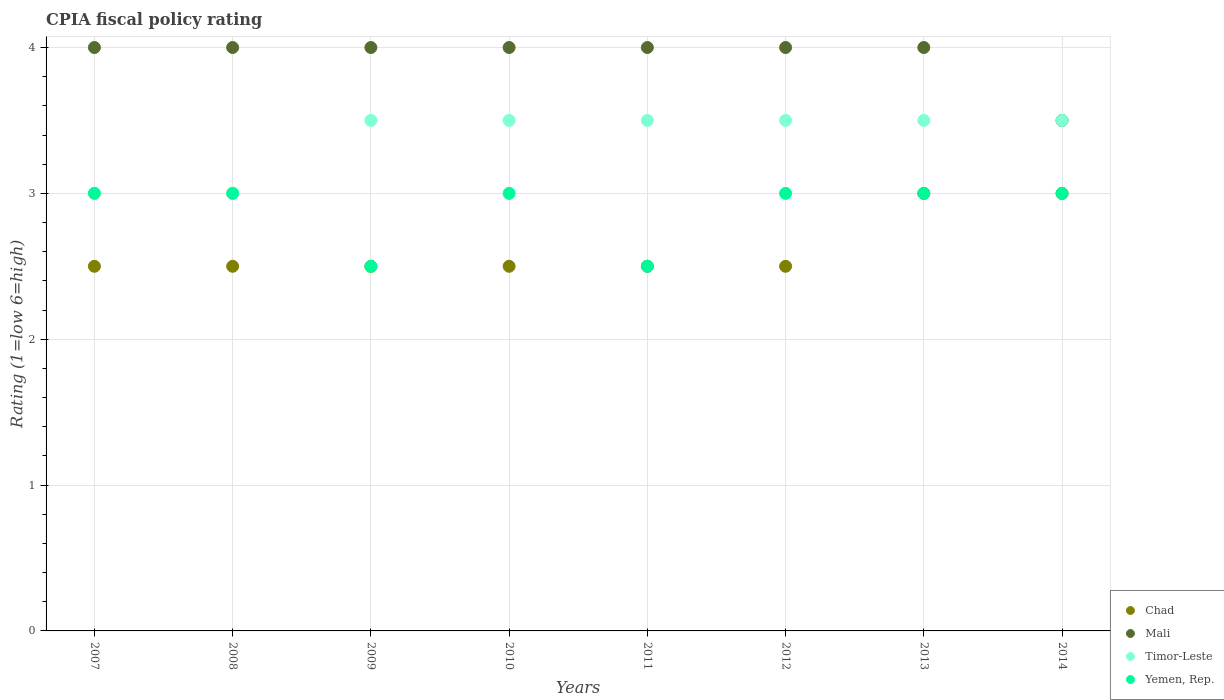Is the number of dotlines equal to the number of legend labels?
Your response must be concise. Yes. Across all years, what is the minimum CPIA rating in Yemen, Rep.?
Your answer should be compact. 2.5. In which year was the CPIA rating in Timor-Leste maximum?
Your response must be concise. 2009. In which year was the CPIA rating in Yemen, Rep. minimum?
Your answer should be very brief. 2009. What is the difference between the CPIA rating in Yemen, Rep. in 2011 and the CPIA rating in Mali in 2012?
Offer a terse response. -1.5. What is the average CPIA rating in Chad per year?
Offer a very short reply. 2.62. In the year 2010, what is the difference between the CPIA rating in Yemen, Rep. and CPIA rating in Chad?
Provide a succinct answer. 0.5. Is the CPIA rating in Chad in 2010 less than that in 2013?
Offer a very short reply. Yes. Is the difference between the CPIA rating in Yemen, Rep. in 2011 and 2013 greater than the difference between the CPIA rating in Chad in 2011 and 2013?
Make the answer very short. No. What is the difference between the highest and the lowest CPIA rating in Chad?
Offer a very short reply. 0.5. In how many years, is the CPIA rating in Mali greater than the average CPIA rating in Mali taken over all years?
Keep it short and to the point. 7. Is it the case that in every year, the sum of the CPIA rating in Chad and CPIA rating in Mali  is greater than the sum of CPIA rating in Yemen, Rep. and CPIA rating in Timor-Leste?
Offer a terse response. Yes. Is it the case that in every year, the sum of the CPIA rating in Timor-Leste and CPIA rating in Chad  is greater than the CPIA rating in Yemen, Rep.?
Offer a terse response. Yes. How many dotlines are there?
Provide a succinct answer. 4. How many years are there in the graph?
Give a very brief answer. 8. Are the values on the major ticks of Y-axis written in scientific E-notation?
Give a very brief answer. No. How many legend labels are there?
Your answer should be very brief. 4. What is the title of the graph?
Provide a short and direct response. CPIA fiscal policy rating. What is the label or title of the X-axis?
Give a very brief answer. Years. What is the Rating (1=low 6=high) of Chad in 2007?
Give a very brief answer. 2.5. What is the Rating (1=low 6=high) in Chad in 2008?
Your answer should be very brief. 2.5. What is the Rating (1=low 6=high) of Timor-Leste in 2008?
Give a very brief answer. 3. What is the Rating (1=low 6=high) of Chad in 2010?
Ensure brevity in your answer.  2.5. What is the Rating (1=low 6=high) of Timor-Leste in 2010?
Provide a short and direct response. 3.5. What is the Rating (1=low 6=high) in Chad in 2011?
Your answer should be compact. 2.5. What is the Rating (1=low 6=high) of Mali in 2011?
Make the answer very short. 4. What is the Rating (1=low 6=high) in Chad in 2012?
Offer a very short reply. 2.5. What is the Rating (1=low 6=high) of Chad in 2013?
Offer a very short reply. 3. What is the Rating (1=low 6=high) in Chad in 2014?
Your answer should be compact. 3. Across all years, what is the maximum Rating (1=low 6=high) of Mali?
Ensure brevity in your answer.  4. Across all years, what is the minimum Rating (1=low 6=high) of Mali?
Provide a short and direct response. 3.5. Across all years, what is the minimum Rating (1=low 6=high) in Timor-Leste?
Your answer should be compact. 3. What is the total Rating (1=low 6=high) in Chad in the graph?
Ensure brevity in your answer.  21. What is the total Rating (1=low 6=high) in Mali in the graph?
Give a very brief answer. 31.5. What is the total Rating (1=low 6=high) in Timor-Leste in the graph?
Offer a terse response. 27. What is the difference between the Rating (1=low 6=high) of Timor-Leste in 2007 and that in 2008?
Offer a terse response. 0. What is the difference between the Rating (1=low 6=high) in Yemen, Rep. in 2007 and that in 2008?
Keep it short and to the point. 0. What is the difference between the Rating (1=low 6=high) of Chad in 2007 and that in 2009?
Keep it short and to the point. 0. What is the difference between the Rating (1=low 6=high) in Mali in 2007 and that in 2010?
Give a very brief answer. 0. What is the difference between the Rating (1=low 6=high) in Yemen, Rep. in 2007 and that in 2010?
Make the answer very short. 0. What is the difference between the Rating (1=low 6=high) in Mali in 2007 and that in 2012?
Make the answer very short. 0. What is the difference between the Rating (1=low 6=high) of Timor-Leste in 2007 and that in 2012?
Ensure brevity in your answer.  -0.5. What is the difference between the Rating (1=low 6=high) of Timor-Leste in 2007 and that in 2013?
Offer a very short reply. -0.5. What is the difference between the Rating (1=low 6=high) in Chad in 2007 and that in 2014?
Offer a very short reply. -0.5. What is the difference between the Rating (1=low 6=high) in Yemen, Rep. in 2007 and that in 2014?
Make the answer very short. 0. What is the difference between the Rating (1=low 6=high) in Mali in 2008 and that in 2009?
Your response must be concise. 0. What is the difference between the Rating (1=low 6=high) in Yemen, Rep. in 2008 and that in 2009?
Provide a short and direct response. 0.5. What is the difference between the Rating (1=low 6=high) of Timor-Leste in 2008 and that in 2010?
Give a very brief answer. -0.5. What is the difference between the Rating (1=low 6=high) in Yemen, Rep. in 2008 and that in 2010?
Your answer should be very brief. 0. What is the difference between the Rating (1=low 6=high) of Chad in 2008 and that in 2011?
Give a very brief answer. 0. What is the difference between the Rating (1=low 6=high) in Yemen, Rep. in 2008 and that in 2011?
Keep it short and to the point. 0.5. What is the difference between the Rating (1=low 6=high) in Chad in 2008 and that in 2012?
Make the answer very short. 0. What is the difference between the Rating (1=low 6=high) of Mali in 2008 and that in 2012?
Your answer should be very brief. 0. What is the difference between the Rating (1=low 6=high) of Yemen, Rep. in 2008 and that in 2012?
Your answer should be compact. 0. What is the difference between the Rating (1=low 6=high) in Mali in 2008 and that in 2013?
Your answer should be very brief. 0. What is the difference between the Rating (1=low 6=high) of Chad in 2008 and that in 2014?
Ensure brevity in your answer.  -0.5. What is the difference between the Rating (1=low 6=high) in Mali in 2009 and that in 2010?
Your answer should be compact. 0. What is the difference between the Rating (1=low 6=high) of Timor-Leste in 2009 and that in 2010?
Your answer should be compact. 0. What is the difference between the Rating (1=low 6=high) of Chad in 2009 and that in 2011?
Ensure brevity in your answer.  0. What is the difference between the Rating (1=low 6=high) of Mali in 2009 and that in 2011?
Your answer should be compact. 0. What is the difference between the Rating (1=low 6=high) of Timor-Leste in 2009 and that in 2011?
Keep it short and to the point. 0. What is the difference between the Rating (1=low 6=high) in Yemen, Rep. in 2009 and that in 2011?
Offer a very short reply. 0. What is the difference between the Rating (1=low 6=high) in Mali in 2009 and that in 2012?
Your response must be concise. 0. What is the difference between the Rating (1=low 6=high) in Timor-Leste in 2009 and that in 2012?
Give a very brief answer. 0. What is the difference between the Rating (1=low 6=high) in Yemen, Rep. in 2009 and that in 2012?
Provide a succinct answer. -0.5. What is the difference between the Rating (1=low 6=high) in Chad in 2009 and that in 2013?
Your answer should be compact. -0.5. What is the difference between the Rating (1=low 6=high) in Timor-Leste in 2009 and that in 2013?
Provide a short and direct response. 0. What is the difference between the Rating (1=low 6=high) of Yemen, Rep. in 2009 and that in 2013?
Your answer should be compact. -0.5. What is the difference between the Rating (1=low 6=high) of Chad in 2009 and that in 2014?
Your answer should be very brief. -0.5. What is the difference between the Rating (1=low 6=high) in Mali in 2009 and that in 2014?
Ensure brevity in your answer.  0.5. What is the difference between the Rating (1=low 6=high) of Chad in 2010 and that in 2011?
Give a very brief answer. 0. What is the difference between the Rating (1=low 6=high) of Chad in 2010 and that in 2012?
Give a very brief answer. 0. What is the difference between the Rating (1=low 6=high) of Mali in 2010 and that in 2012?
Provide a succinct answer. 0. What is the difference between the Rating (1=low 6=high) of Chad in 2010 and that in 2013?
Ensure brevity in your answer.  -0.5. What is the difference between the Rating (1=low 6=high) of Timor-Leste in 2010 and that in 2013?
Your answer should be very brief. 0. What is the difference between the Rating (1=low 6=high) in Chad in 2010 and that in 2014?
Provide a succinct answer. -0.5. What is the difference between the Rating (1=low 6=high) in Mali in 2010 and that in 2014?
Ensure brevity in your answer.  0.5. What is the difference between the Rating (1=low 6=high) in Timor-Leste in 2010 and that in 2014?
Offer a terse response. 0. What is the difference between the Rating (1=low 6=high) of Yemen, Rep. in 2010 and that in 2014?
Your answer should be compact. 0. What is the difference between the Rating (1=low 6=high) of Mali in 2011 and that in 2012?
Provide a short and direct response. 0. What is the difference between the Rating (1=low 6=high) of Timor-Leste in 2011 and that in 2013?
Make the answer very short. 0. What is the difference between the Rating (1=low 6=high) in Yemen, Rep. in 2011 and that in 2013?
Give a very brief answer. -0.5. What is the difference between the Rating (1=low 6=high) of Mali in 2011 and that in 2014?
Your response must be concise. 0.5. What is the difference between the Rating (1=low 6=high) of Yemen, Rep. in 2011 and that in 2014?
Offer a very short reply. -0.5. What is the difference between the Rating (1=low 6=high) of Chad in 2012 and that in 2013?
Offer a very short reply. -0.5. What is the difference between the Rating (1=low 6=high) of Mali in 2012 and that in 2013?
Provide a short and direct response. 0. What is the difference between the Rating (1=low 6=high) in Timor-Leste in 2012 and that in 2013?
Offer a terse response. 0. What is the difference between the Rating (1=low 6=high) of Yemen, Rep. in 2012 and that in 2013?
Offer a terse response. 0. What is the difference between the Rating (1=low 6=high) of Chad in 2012 and that in 2014?
Ensure brevity in your answer.  -0.5. What is the difference between the Rating (1=low 6=high) of Chad in 2013 and that in 2014?
Your answer should be compact. 0. What is the difference between the Rating (1=low 6=high) in Mali in 2013 and that in 2014?
Keep it short and to the point. 0.5. What is the difference between the Rating (1=low 6=high) of Chad in 2007 and the Rating (1=low 6=high) of Mali in 2008?
Provide a succinct answer. -1.5. What is the difference between the Rating (1=low 6=high) in Chad in 2007 and the Rating (1=low 6=high) in Timor-Leste in 2008?
Offer a terse response. -0.5. What is the difference between the Rating (1=low 6=high) of Chad in 2007 and the Rating (1=low 6=high) of Yemen, Rep. in 2008?
Your response must be concise. -0.5. What is the difference between the Rating (1=low 6=high) in Mali in 2007 and the Rating (1=low 6=high) in Timor-Leste in 2008?
Your answer should be compact. 1. What is the difference between the Rating (1=low 6=high) of Mali in 2007 and the Rating (1=low 6=high) of Yemen, Rep. in 2008?
Offer a terse response. 1. What is the difference between the Rating (1=low 6=high) of Timor-Leste in 2007 and the Rating (1=low 6=high) of Yemen, Rep. in 2008?
Your answer should be very brief. 0. What is the difference between the Rating (1=low 6=high) in Chad in 2007 and the Rating (1=low 6=high) in Mali in 2009?
Keep it short and to the point. -1.5. What is the difference between the Rating (1=low 6=high) in Chad in 2007 and the Rating (1=low 6=high) in Timor-Leste in 2009?
Give a very brief answer. -1. What is the difference between the Rating (1=low 6=high) of Chad in 2007 and the Rating (1=low 6=high) of Yemen, Rep. in 2009?
Keep it short and to the point. 0. What is the difference between the Rating (1=low 6=high) of Mali in 2007 and the Rating (1=low 6=high) of Timor-Leste in 2009?
Offer a very short reply. 0.5. What is the difference between the Rating (1=low 6=high) in Mali in 2007 and the Rating (1=low 6=high) in Yemen, Rep. in 2009?
Keep it short and to the point. 1.5. What is the difference between the Rating (1=low 6=high) in Timor-Leste in 2007 and the Rating (1=low 6=high) in Yemen, Rep. in 2009?
Provide a short and direct response. 0.5. What is the difference between the Rating (1=low 6=high) in Chad in 2007 and the Rating (1=low 6=high) in Yemen, Rep. in 2010?
Your response must be concise. -0.5. What is the difference between the Rating (1=low 6=high) of Mali in 2007 and the Rating (1=low 6=high) of Yemen, Rep. in 2010?
Ensure brevity in your answer.  1. What is the difference between the Rating (1=low 6=high) in Chad in 2007 and the Rating (1=low 6=high) in Mali in 2011?
Offer a very short reply. -1.5. What is the difference between the Rating (1=low 6=high) in Chad in 2007 and the Rating (1=low 6=high) in Timor-Leste in 2011?
Your response must be concise. -1. What is the difference between the Rating (1=low 6=high) of Chad in 2007 and the Rating (1=low 6=high) of Yemen, Rep. in 2011?
Provide a succinct answer. 0. What is the difference between the Rating (1=low 6=high) of Timor-Leste in 2007 and the Rating (1=low 6=high) of Yemen, Rep. in 2011?
Ensure brevity in your answer.  0.5. What is the difference between the Rating (1=low 6=high) of Chad in 2007 and the Rating (1=low 6=high) of Mali in 2012?
Provide a short and direct response. -1.5. What is the difference between the Rating (1=low 6=high) in Chad in 2007 and the Rating (1=low 6=high) in Timor-Leste in 2012?
Your response must be concise. -1. What is the difference between the Rating (1=low 6=high) in Chad in 2007 and the Rating (1=low 6=high) in Yemen, Rep. in 2012?
Make the answer very short. -0.5. What is the difference between the Rating (1=low 6=high) of Mali in 2007 and the Rating (1=low 6=high) of Timor-Leste in 2012?
Provide a short and direct response. 0.5. What is the difference between the Rating (1=low 6=high) of Timor-Leste in 2007 and the Rating (1=low 6=high) of Yemen, Rep. in 2012?
Ensure brevity in your answer.  0. What is the difference between the Rating (1=low 6=high) of Chad in 2007 and the Rating (1=low 6=high) of Mali in 2013?
Offer a terse response. -1.5. What is the difference between the Rating (1=low 6=high) in Chad in 2007 and the Rating (1=low 6=high) in Timor-Leste in 2013?
Ensure brevity in your answer.  -1. What is the difference between the Rating (1=low 6=high) in Chad in 2007 and the Rating (1=low 6=high) in Yemen, Rep. in 2013?
Offer a very short reply. -0.5. What is the difference between the Rating (1=low 6=high) of Mali in 2007 and the Rating (1=low 6=high) of Timor-Leste in 2013?
Provide a short and direct response. 0.5. What is the difference between the Rating (1=low 6=high) of Mali in 2007 and the Rating (1=low 6=high) of Yemen, Rep. in 2013?
Your answer should be very brief. 1. What is the difference between the Rating (1=low 6=high) in Mali in 2007 and the Rating (1=low 6=high) in Timor-Leste in 2014?
Make the answer very short. 0.5. What is the difference between the Rating (1=low 6=high) of Mali in 2007 and the Rating (1=low 6=high) of Yemen, Rep. in 2014?
Offer a terse response. 1. What is the difference between the Rating (1=low 6=high) of Timor-Leste in 2007 and the Rating (1=low 6=high) of Yemen, Rep. in 2014?
Offer a terse response. 0. What is the difference between the Rating (1=low 6=high) in Chad in 2008 and the Rating (1=low 6=high) in Mali in 2009?
Offer a terse response. -1.5. What is the difference between the Rating (1=low 6=high) of Chad in 2008 and the Rating (1=low 6=high) of Yemen, Rep. in 2009?
Offer a very short reply. 0. What is the difference between the Rating (1=low 6=high) of Mali in 2008 and the Rating (1=low 6=high) of Yemen, Rep. in 2009?
Keep it short and to the point. 1.5. What is the difference between the Rating (1=low 6=high) in Timor-Leste in 2008 and the Rating (1=low 6=high) in Yemen, Rep. in 2009?
Keep it short and to the point. 0.5. What is the difference between the Rating (1=low 6=high) in Chad in 2008 and the Rating (1=low 6=high) in Yemen, Rep. in 2010?
Offer a very short reply. -0.5. What is the difference between the Rating (1=low 6=high) of Mali in 2008 and the Rating (1=low 6=high) of Yemen, Rep. in 2010?
Offer a terse response. 1. What is the difference between the Rating (1=low 6=high) of Timor-Leste in 2008 and the Rating (1=low 6=high) of Yemen, Rep. in 2010?
Your response must be concise. 0. What is the difference between the Rating (1=low 6=high) in Chad in 2008 and the Rating (1=low 6=high) in Timor-Leste in 2011?
Make the answer very short. -1. What is the difference between the Rating (1=low 6=high) in Chad in 2008 and the Rating (1=low 6=high) in Yemen, Rep. in 2011?
Your answer should be very brief. 0. What is the difference between the Rating (1=low 6=high) of Mali in 2008 and the Rating (1=low 6=high) of Timor-Leste in 2011?
Make the answer very short. 0.5. What is the difference between the Rating (1=low 6=high) in Mali in 2008 and the Rating (1=low 6=high) in Yemen, Rep. in 2011?
Offer a very short reply. 1.5. What is the difference between the Rating (1=low 6=high) of Chad in 2008 and the Rating (1=low 6=high) of Timor-Leste in 2012?
Your answer should be very brief. -1. What is the difference between the Rating (1=low 6=high) of Chad in 2008 and the Rating (1=low 6=high) of Mali in 2013?
Offer a very short reply. -1.5. What is the difference between the Rating (1=low 6=high) in Mali in 2008 and the Rating (1=low 6=high) in Timor-Leste in 2013?
Ensure brevity in your answer.  0.5. What is the difference between the Rating (1=low 6=high) in Mali in 2008 and the Rating (1=low 6=high) in Yemen, Rep. in 2013?
Offer a very short reply. 1. What is the difference between the Rating (1=low 6=high) of Timor-Leste in 2008 and the Rating (1=low 6=high) of Yemen, Rep. in 2013?
Your response must be concise. 0. What is the difference between the Rating (1=low 6=high) in Chad in 2008 and the Rating (1=low 6=high) in Mali in 2014?
Make the answer very short. -1. What is the difference between the Rating (1=low 6=high) of Chad in 2008 and the Rating (1=low 6=high) of Timor-Leste in 2014?
Ensure brevity in your answer.  -1. What is the difference between the Rating (1=low 6=high) in Mali in 2008 and the Rating (1=low 6=high) in Yemen, Rep. in 2014?
Provide a succinct answer. 1. What is the difference between the Rating (1=low 6=high) of Timor-Leste in 2008 and the Rating (1=low 6=high) of Yemen, Rep. in 2014?
Ensure brevity in your answer.  0. What is the difference between the Rating (1=low 6=high) of Chad in 2009 and the Rating (1=low 6=high) of Mali in 2010?
Provide a succinct answer. -1.5. What is the difference between the Rating (1=low 6=high) in Chad in 2009 and the Rating (1=low 6=high) in Timor-Leste in 2010?
Your answer should be very brief. -1. What is the difference between the Rating (1=low 6=high) of Chad in 2009 and the Rating (1=low 6=high) of Yemen, Rep. in 2010?
Offer a very short reply. -0.5. What is the difference between the Rating (1=low 6=high) of Chad in 2009 and the Rating (1=low 6=high) of Mali in 2011?
Your answer should be very brief. -1.5. What is the difference between the Rating (1=low 6=high) in Chad in 2009 and the Rating (1=low 6=high) in Yemen, Rep. in 2011?
Keep it short and to the point. 0. What is the difference between the Rating (1=low 6=high) in Mali in 2009 and the Rating (1=low 6=high) in Timor-Leste in 2011?
Your answer should be very brief. 0.5. What is the difference between the Rating (1=low 6=high) in Timor-Leste in 2009 and the Rating (1=low 6=high) in Yemen, Rep. in 2011?
Offer a very short reply. 1. What is the difference between the Rating (1=low 6=high) in Chad in 2009 and the Rating (1=low 6=high) in Timor-Leste in 2012?
Offer a very short reply. -1. What is the difference between the Rating (1=low 6=high) of Chad in 2009 and the Rating (1=low 6=high) of Yemen, Rep. in 2012?
Give a very brief answer. -0.5. What is the difference between the Rating (1=low 6=high) in Mali in 2009 and the Rating (1=low 6=high) in Timor-Leste in 2012?
Provide a succinct answer. 0.5. What is the difference between the Rating (1=low 6=high) of Timor-Leste in 2009 and the Rating (1=low 6=high) of Yemen, Rep. in 2012?
Provide a succinct answer. 0.5. What is the difference between the Rating (1=low 6=high) of Chad in 2009 and the Rating (1=low 6=high) of Mali in 2013?
Provide a succinct answer. -1.5. What is the difference between the Rating (1=low 6=high) of Chad in 2009 and the Rating (1=low 6=high) of Yemen, Rep. in 2013?
Your response must be concise. -0.5. What is the difference between the Rating (1=low 6=high) of Mali in 2009 and the Rating (1=low 6=high) of Yemen, Rep. in 2013?
Provide a short and direct response. 1. What is the difference between the Rating (1=low 6=high) of Chad in 2009 and the Rating (1=low 6=high) of Mali in 2014?
Ensure brevity in your answer.  -1. What is the difference between the Rating (1=low 6=high) of Chad in 2009 and the Rating (1=low 6=high) of Timor-Leste in 2014?
Your response must be concise. -1. What is the difference between the Rating (1=low 6=high) in Chad in 2009 and the Rating (1=low 6=high) in Yemen, Rep. in 2014?
Provide a succinct answer. -0.5. What is the difference between the Rating (1=low 6=high) of Mali in 2009 and the Rating (1=low 6=high) of Yemen, Rep. in 2014?
Ensure brevity in your answer.  1. What is the difference between the Rating (1=low 6=high) of Timor-Leste in 2009 and the Rating (1=low 6=high) of Yemen, Rep. in 2014?
Give a very brief answer. 0.5. What is the difference between the Rating (1=low 6=high) in Chad in 2010 and the Rating (1=low 6=high) in Mali in 2011?
Keep it short and to the point. -1.5. What is the difference between the Rating (1=low 6=high) in Chad in 2010 and the Rating (1=low 6=high) in Yemen, Rep. in 2011?
Your answer should be very brief. 0. What is the difference between the Rating (1=low 6=high) in Mali in 2010 and the Rating (1=low 6=high) in Timor-Leste in 2011?
Keep it short and to the point. 0.5. What is the difference between the Rating (1=low 6=high) of Chad in 2010 and the Rating (1=low 6=high) of Mali in 2012?
Make the answer very short. -1.5. What is the difference between the Rating (1=low 6=high) in Chad in 2010 and the Rating (1=low 6=high) in Timor-Leste in 2012?
Make the answer very short. -1. What is the difference between the Rating (1=low 6=high) of Chad in 2010 and the Rating (1=low 6=high) of Yemen, Rep. in 2012?
Make the answer very short. -0.5. What is the difference between the Rating (1=low 6=high) of Timor-Leste in 2010 and the Rating (1=low 6=high) of Yemen, Rep. in 2012?
Your response must be concise. 0.5. What is the difference between the Rating (1=low 6=high) of Chad in 2010 and the Rating (1=low 6=high) of Timor-Leste in 2013?
Offer a terse response. -1. What is the difference between the Rating (1=low 6=high) in Mali in 2010 and the Rating (1=low 6=high) in Timor-Leste in 2013?
Offer a terse response. 0.5. What is the difference between the Rating (1=low 6=high) of Timor-Leste in 2010 and the Rating (1=low 6=high) of Yemen, Rep. in 2013?
Provide a short and direct response. 0.5. What is the difference between the Rating (1=low 6=high) in Chad in 2010 and the Rating (1=low 6=high) in Mali in 2014?
Your response must be concise. -1. What is the difference between the Rating (1=low 6=high) of Mali in 2010 and the Rating (1=low 6=high) of Yemen, Rep. in 2014?
Provide a succinct answer. 1. What is the difference between the Rating (1=low 6=high) of Timor-Leste in 2010 and the Rating (1=low 6=high) of Yemen, Rep. in 2014?
Offer a terse response. 0.5. What is the difference between the Rating (1=low 6=high) of Chad in 2011 and the Rating (1=low 6=high) of Mali in 2012?
Provide a short and direct response. -1.5. What is the difference between the Rating (1=low 6=high) in Chad in 2011 and the Rating (1=low 6=high) in Timor-Leste in 2012?
Ensure brevity in your answer.  -1. What is the difference between the Rating (1=low 6=high) of Mali in 2011 and the Rating (1=low 6=high) of Yemen, Rep. in 2012?
Keep it short and to the point. 1. What is the difference between the Rating (1=low 6=high) in Chad in 2011 and the Rating (1=low 6=high) in Timor-Leste in 2013?
Your response must be concise. -1. What is the difference between the Rating (1=low 6=high) of Mali in 2011 and the Rating (1=low 6=high) of Timor-Leste in 2013?
Your response must be concise. 0.5. What is the difference between the Rating (1=low 6=high) in Timor-Leste in 2011 and the Rating (1=low 6=high) in Yemen, Rep. in 2013?
Provide a short and direct response. 0.5. What is the difference between the Rating (1=low 6=high) of Chad in 2011 and the Rating (1=low 6=high) of Mali in 2014?
Your answer should be compact. -1. What is the difference between the Rating (1=low 6=high) of Chad in 2011 and the Rating (1=low 6=high) of Timor-Leste in 2014?
Provide a succinct answer. -1. What is the difference between the Rating (1=low 6=high) in Chad in 2011 and the Rating (1=low 6=high) in Yemen, Rep. in 2014?
Provide a succinct answer. -0.5. What is the difference between the Rating (1=low 6=high) in Mali in 2011 and the Rating (1=low 6=high) in Timor-Leste in 2014?
Keep it short and to the point. 0.5. What is the difference between the Rating (1=low 6=high) in Mali in 2011 and the Rating (1=low 6=high) in Yemen, Rep. in 2014?
Your answer should be compact. 1. What is the difference between the Rating (1=low 6=high) in Chad in 2012 and the Rating (1=low 6=high) in Mali in 2013?
Offer a terse response. -1.5. What is the difference between the Rating (1=low 6=high) in Chad in 2012 and the Rating (1=low 6=high) in Timor-Leste in 2013?
Offer a terse response. -1. What is the difference between the Rating (1=low 6=high) in Chad in 2012 and the Rating (1=low 6=high) in Mali in 2014?
Your response must be concise. -1. What is the difference between the Rating (1=low 6=high) of Chad in 2012 and the Rating (1=low 6=high) of Yemen, Rep. in 2014?
Offer a very short reply. -0.5. What is the difference between the Rating (1=low 6=high) of Mali in 2012 and the Rating (1=low 6=high) of Timor-Leste in 2014?
Your answer should be very brief. 0.5. What is the difference between the Rating (1=low 6=high) in Timor-Leste in 2012 and the Rating (1=low 6=high) in Yemen, Rep. in 2014?
Give a very brief answer. 0.5. What is the difference between the Rating (1=low 6=high) in Chad in 2013 and the Rating (1=low 6=high) in Mali in 2014?
Your answer should be compact. -0.5. What is the difference between the Rating (1=low 6=high) of Mali in 2013 and the Rating (1=low 6=high) of Timor-Leste in 2014?
Keep it short and to the point. 0.5. What is the difference between the Rating (1=low 6=high) in Timor-Leste in 2013 and the Rating (1=low 6=high) in Yemen, Rep. in 2014?
Offer a terse response. 0.5. What is the average Rating (1=low 6=high) of Chad per year?
Give a very brief answer. 2.62. What is the average Rating (1=low 6=high) in Mali per year?
Provide a succinct answer. 3.94. What is the average Rating (1=low 6=high) in Timor-Leste per year?
Provide a short and direct response. 3.38. What is the average Rating (1=low 6=high) of Yemen, Rep. per year?
Provide a short and direct response. 2.88. In the year 2007, what is the difference between the Rating (1=low 6=high) in Timor-Leste and Rating (1=low 6=high) in Yemen, Rep.?
Your answer should be very brief. 0. In the year 2008, what is the difference between the Rating (1=low 6=high) of Chad and Rating (1=low 6=high) of Timor-Leste?
Provide a short and direct response. -0.5. In the year 2008, what is the difference between the Rating (1=low 6=high) in Mali and Rating (1=low 6=high) in Yemen, Rep.?
Offer a very short reply. 1. In the year 2008, what is the difference between the Rating (1=low 6=high) of Timor-Leste and Rating (1=low 6=high) of Yemen, Rep.?
Your answer should be very brief. 0. In the year 2009, what is the difference between the Rating (1=low 6=high) in Chad and Rating (1=low 6=high) in Mali?
Ensure brevity in your answer.  -1.5. In the year 2009, what is the difference between the Rating (1=low 6=high) of Chad and Rating (1=low 6=high) of Yemen, Rep.?
Make the answer very short. 0. In the year 2009, what is the difference between the Rating (1=low 6=high) in Mali and Rating (1=low 6=high) in Yemen, Rep.?
Keep it short and to the point. 1.5. In the year 2010, what is the difference between the Rating (1=low 6=high) in Chad and Rating (1=low 6=high) in Mali?
Offer a very short reply. -1.5. In the year 2010, what is the difference between the Rating (1=low 6=high) of Chad and Rating (1=low 6=high) of Timor-Leste?
Your answer should be compact. -1. In the year 2010, what is the difference between the Rating (1=low 6=high) of Chad and Rating (1=low 6=high) of Yemen, Rep.?
Your answer should be compact. -0.5. In the year 2010, what is the difference between the Rating (1=low 6=high) of Mali and Rating (1=low 6=high) of Yemen, Rep.?
Give a very brief answer. 1. In the year 2010, what is the difference between the Rating (1=low 6=high) of Timor-Leste and Rating (1=low 6=high) of Yemen, Rep.?
Your answer should be very brief. 0.5. In the year 2011, what is the difference between the Rating (1=low 6=high) of Chad and Rating (1=low 6=high) of Mali?
Offer a terse response. -1.5. In the year 2011, what is the difference between the Rating (1=low 6=high) in Chad and Rating (1=low 6=high) in Timor-Leste?
Provide a short and direct response. -1. In the year 2011, what is the difference between the Rating (1=low 6=high) in Mali and Rating (1=low 6=high) in Yemen, Rep.?
Make the answer very short. 1.5. In the year 2011, what is the difference between the Rating (1=low 6=high) of Timor-Leste and Rating (1=low 6=high) of Yemen, Rep.?
Provide a succinct answer. 1. In the year 2012, what is the difference between the Rating (1=low 6=high) of Chad and Rating (1=low 6=high) of Yemen, Rep.?
Your answer should be compact. -0.5. In the year 2013, what is the difference between the Rating (1=low 6=high) of Chad and Rating (1=low 6=high) of Mali?
Your response must be concise. -1. In the year 2013, what is the difference between the Rating (1=low 6=high) of Mali and Rating (1=low 6=high) of Timor-Leste?
Provide a succinct answer. 0.5. In the year 2013, what is the difference between the Rating (1=low 6=high) in Timor-Leste and Rating (1=low 6=high) in Yemen, Rep.?
Provide a short and direct response. 0.5. In the year 2014, what is the difference between the Rating (1=low 6=high) in Chad and Rating (1=low 6=high) in Yemen, Rep.?
Offer a terse response. 0. In the year 2014, what is the difference between the Rating (1=low 6=high) of Mali and Rating (1=low 6=high) of Timor-Leste?
Provide a short and direct response. 0. In the year 2014, what is the difference between the Rating (1=low 6=high) of Mali and Rating (1=low 6=high) of Yemen, Rep.?
Make the answer very short. 0.5. What is the ratio of the Rating (1=low 6=high) of Mali in 2007 to that in 2008?
Give a very brief answer. 1. What is the ratio of the Rating (1=low 6=high) in Timor-Leste in 2007 to that in 2008?
Make the answer very short. 1. What is the ratio of the Rating (1=low 6=high) of Yemen, Rep. in 2007 to that in 2008?
Your answer should be compact. 1. What is the ratio of the Rating (1=low 6=high) of Chad in 2007 to that in 2009?
Provide a succinct answer. 1. What is the ratio of the Rating (1=low 6=high) of Mali in 2007 to that in 2009?
Give a very brief answer. 1. What is the ratio of the Rating (1=low 6=high) of Timor-Leste in 2007 to that in 2009?
Offer a terse response. 0.86. What is the ratio of the Rating (1=low 6=high) of Yemen, Rep. in 2007 to that in 2009?
Give a very brief answer. 1.2. What is the ratio of the Rating (1=low 6=high) in Chad in 2007 to that in 2010?
Your answer should be very brief. 1. What is the ratio of the Rating (1=low 6=high) of Mali in 2007 to that in 2010?
Ensure brevity in your answer.  1. What is the ratio of the Rating (1=low 6=high) of Mali in 2007 to that in 2011?
Offer a very short reply. 1. What is the ratio of the Rating (1=low 6=high) in Timor-Leste in 2007 to that in 2011?
Keep it short and to the point. 0.86. What is the ratio of the Rating (1=low 6=high) in Mali in 2007 to that in 2012?
Offer a terse response. 1. What is the ratio of the Rating (1=low 6=high) of Yemen, Rep. in 2007 to that in 2012?
Provide a short and direct response. 1. What is the ratio of the Rating (1=low 6=high) in Mali in 2007 to that in 2013?
Give a very brief answer. 1. What is the ratio of the Rating (1=low 6=high) in Yemen, Rep. in 2007 to that in 2013?
Offer a terse response. 1. What is the ratio of the Rating (1=low 6=high) in Mali in 2007 to that in 2014?
Make the answer very short. 1.14. What is the ratio of the Rating (1=low 6=high) in Yemen, Rep. in 2007 to that in 2014?
Provide a succinct answer. 1. What is the ratio of the Rating (1=low 6=high) of Chad in 2008 to that in 2009?
Your answer should be very brief. 1. What is the ratio of the Rating (1=low 6=high) of Yemen, Rep. in 2008 to that in 2009?
Give a very brief answer. 1.2. What is the ratio of the Rating (1=low 6=high) of Timor-Leste in 2008 to that in 2010?
Offer a very short reply. 0.86. What is the ratio of the Rating (1=low 6=high) in Yemen, Rep. in 2008 to that in 2010?
Provide a short and direct response. 1. What is the ratio of the Rating (1=low 6=high) in Timor-Leste in 2008 to that in 2011?
Your response must be concise. 0.86. What is the ratio of the Rating (1=low 6=high) in Yemen, Rep. in 2008 to that in 2011?
Make the answer very short. 1.2. What is the ratio of the Rating (1=low 6=high) in Chad in 2008 to that in 2012?
Your answer should be compact. 1. What is the ratio of the Rating (1=low 6=high) of Chad in 2008 to that in 2013?
Your answer should be very brief. 0.83. What is the ratio of the Rating (1=low 6=high) of Mali in 2008 to that in 2013?
Make the answer very short. 1. What is the ratio of the Rating (1=low 6=high) of Yemen, Rep. in 2008 to that in 2013?
Offer a terse response. 1. What is the ratio of the Rating (1=low 6=high) in Chad in 2008 to that in 2014?
Provide a succinct answer. 0.83. What is the ratio of the Rating (1=low 6=high) of Timor-Leste in 2008 to that in 2014?
Offer a very short reply. 0.86. What is the ratio of the Rating (1=low 6=high) in Chad in 2009 to that in 2010?
Provide a succinct answer. 1. What is the ratio of the Rating (1=low 6=high) in Timor-Leste in 2009 to that in 2010?
Ensure brevity in your answer.  1. What is the ratio of the Rating (1=low 6=high) in Yemen, Rep. in 2009 to that in 2010?
Provide a succinct answer. 0.83. What is the ratio of the Rating (1=low 6=high) of Mali in 2009 to that in 2011?
Give a very brief answer. 1. What is the ratio of the Rating (1=low 6=high) in Chad in 2009 to that in 2012?
Your answer should be compact. 1. What is the ratio of the Rating (1=low 6=high) of Mali in 2009 to that in 2012?
Your answer should be compact. 1. What is the ratio of the Rating (1=low 6=high) in Yemen, Rep. in 2009 to that in 2012?
Your response must be concise. 0.83. What is the ratio of the Rating (1=low 6=high) in Mali in 2009 to that in 2013?
Offer a terse response. 1. What is the ratio of the Rating (1=low 6=high) of Chad in 2009 to that in 2014?
Provide a short and direct response. 0.83. What is the ratio of the Rating (1=low 6=high) in Mali in 2009 to that in 2014?
Your response must be concise. 1.14. What is the ratio of the Rating (1=low 6=high) in Mali in 2010 to that in 2011?
Provide a succinct answer. 1. What is the ratio of the Rating (1=low 6=high) of Timor-Leste in 2010 to that in 2011?
Offer a terse response. 1. What is the ratio of the Rating (1=low 6=high) in Yemen, Rep. in 2010 to that in 2011?
Keep it short and to the point. 1.2. What is the ratio of the Rating (1=low 6=high) of Mali in 2010 to that in 2012?
Give a very brief answer. 1. What is the ratio of the Rating (1=low 6=high) in Chad in 2010 to that in 2013?
Give a very brief answer. 0.83. What is the ratio of the Rating (1=low 6=high) in Mali in 2010 to that in 2013?
Your answer should be compact. 1. What is the ratio of the Rating (1=low 6=high) of Timor-Leste in 2010 to that in 2013?
Ensure brevity in your answer.  1. What is the ratio of the Rating (1=low 6=high) of Yemen, Rep. in 2010 to that in 2013?
Offer a terse response. 1. What is the ratio of the Rating (1=low 6=high) of Mali in 2010 to that in 2014?
Make the answer very short. 1.14. What is the ratio of the Rating (1=low 6=high) of Timor-Leste in 2010 to that in 2014?
Provide a short and direct response. 1. What is the ratio of the Rating (1=low 6=high) in Mali in 2011 to that in 2012?
Your answer should be compact. 1. What is the ratio of the Rating (1=low 6=high) of Timor-Leste in 2011 to that in 2012?
Your response must be concise. 1. What is the ratio of the Rating (1=low 6=high) of Yemen, Rep. in 2011 to that in 2012?
Offer a very short reply. 0.83. What is the ratio of the Rating (1=low 6=high) of Chad in 2011 to that in 2013?
Make the answer very short. 0.83. What is the ratio of the Rating (1=low 6=high) of Timor-Leste in 2011 to that in 2013?
Offer a terse response. 1. What is the ratio of the Rating (1=low 6=high) in Mali in 2011 to that in 2014?
Make the answer very short. 1.14. What is the ratio of the Rating (1=low 6=high) in Timor-Leste in 2011 to that in 2014?
Provide a short and direct response. 1. What is the ratio of the Rating (1=low 6=high) in Chad in 2012 to that in 2014?
Offer a very short reply. 0.83. What is the ratio of the Rating (1=low 6=high) in Chad in 2013 to that in 2014?
Provide a short and direct response. 1. What is the ratio of the Rating (1=low 6=high) in Timor-Leste in 2013 to that in 2014?
Keep it short and to the point. 1. What is the ratio of the Rating (1=low 6=high) in Yemen, Rep. in 2013 to that in 2014?
Your answer should be very brief. 1. What is the difference between the highest and the second highest Rating (1=low 6=high) in Chad?
Offer a terse response. 0. What is the difference between the highest and the second highest Rating (1=low 6=high) of Yemen, Rep.?
Keep it short and to the point. 0. What is the difference between the highest and the lowest Rating (1=low 6=high) in Chad?
Ensure brevity in your answer.  0.5. What is the difference between the highest and the lowest Rating (1=low 6=high) in Mali?
Make the answer very short. 0.5. What is the difference between the highest and the lowest Rating (1=low 6=high) in Timor-Leste?
Provide a short and direct response. 0.5. What is the difference between the highest and the lowest Rating (1=low 6=high) in Yemen, Rep.?
Give a very brief answer. 0.5. 